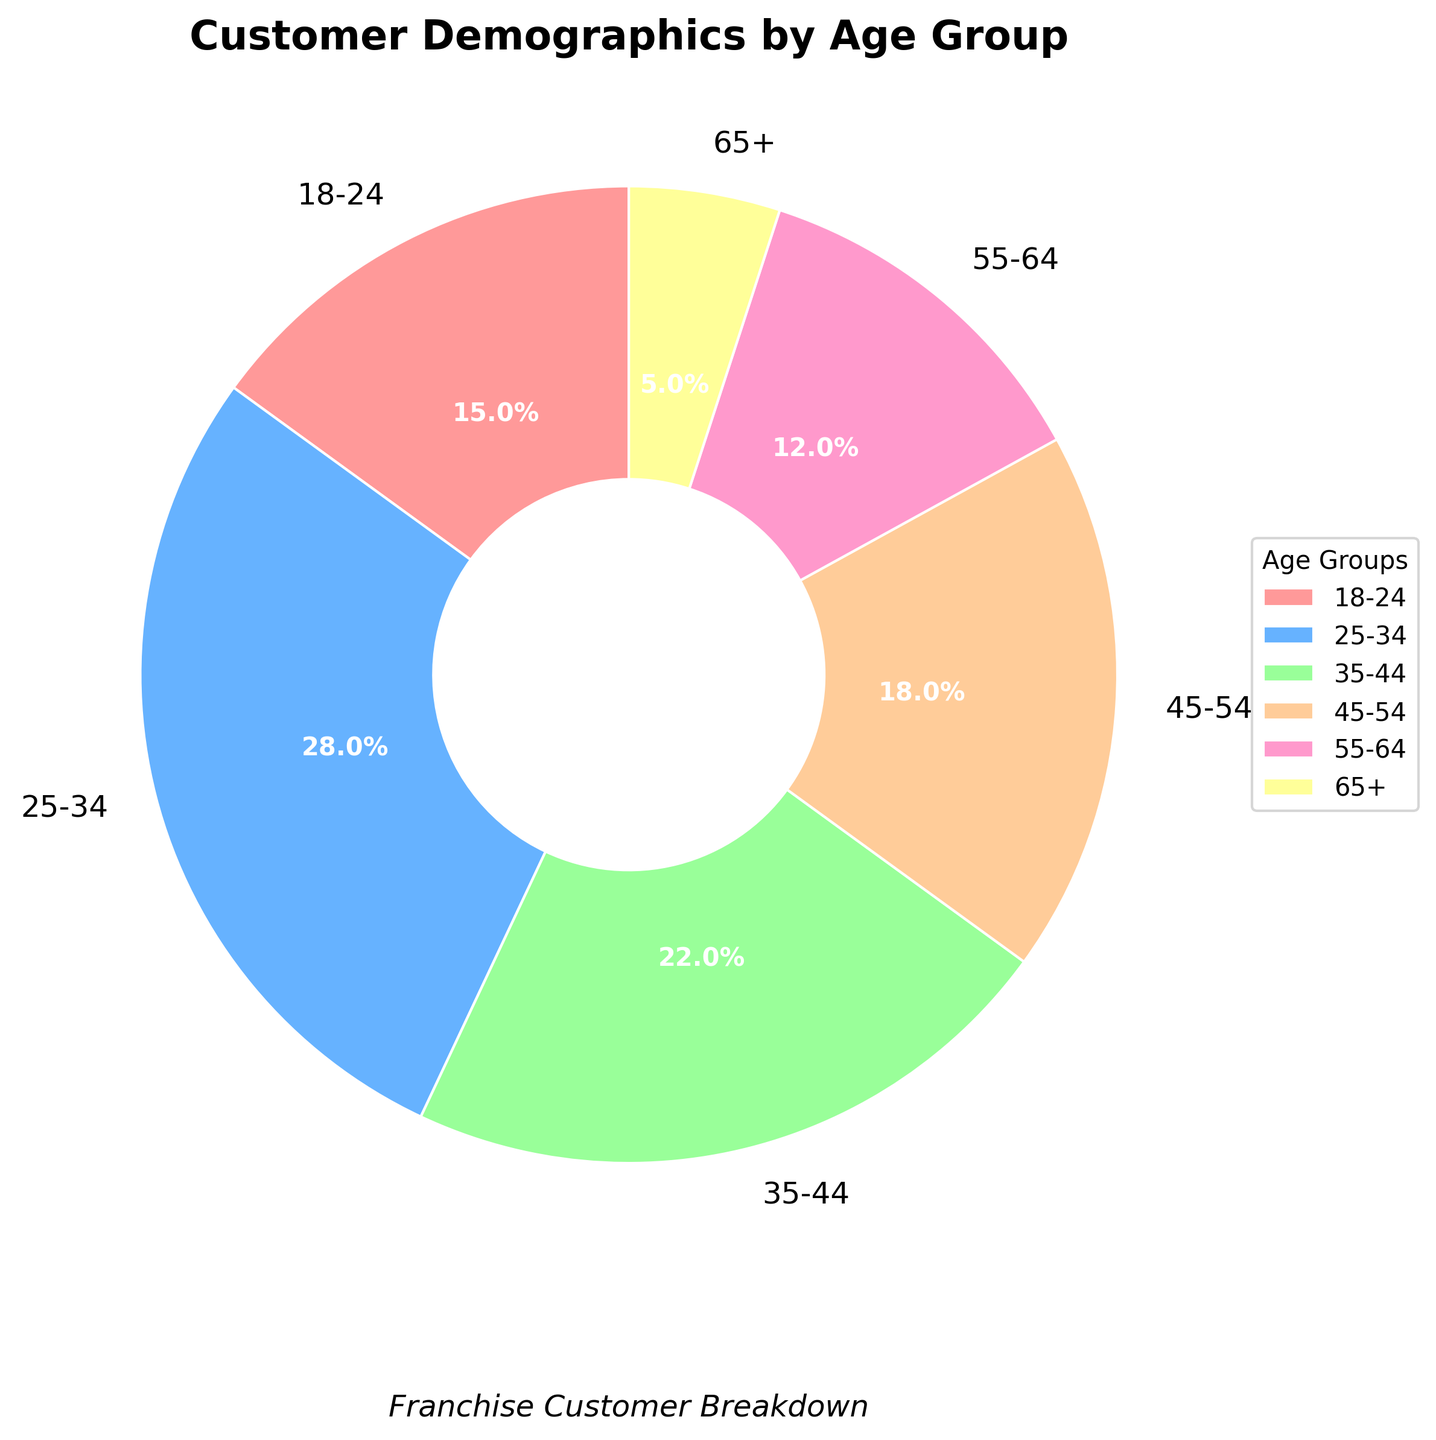Which age group has the highest percentage of customers? The pie chart shows the largest segment with a label indicating 28% for the 25-34 age group.
Answer: 25-34 What is the combined percentage of customers aged 45 and above? To find the combined percentage, add the percentages of age groups 45-54, 55-64, and 65+. These are 18%, 12%, and 5% respectively, so 18 + 12 + 5 = 35%.
Answer: 35% Which age group accounts for less than 10% of the customer base? The pie chart shows the smallest segment labeled 5% for the 65+ age group, which is less than 10%.
Answer: 65+ How much larger is the percentage of customers aged 25-34 compared to those aged 55-64? Subtract the percentage of customers aged 55-64 from those aged 25-34. So, 28% - 12% = 16%.
Answer: 16% Are there more customers aged 35-44 or 45-54? The pie chart shows 22% for the 35-44 age group and 18% for the 45-54 age group. 22% is greater than 18%.
Answer: 35-44 What percentage of customers is aged 18-24? The pie chart shows the percentage of the 18-24 age group as 15%.
Answer: 15% How many age groups have more than 20% of the customers? The pie chart indicates that only two age groups have more than 20%: 25-34 (28%) and 35-44 (22%).
Answer: 2 Which two age groups combined have nearly the same percentage as the 25-34 age group? Combining 18-24 and 55-64 age groups will give 15% + 12% = 27%, which is nearly 28%.
Answer: 18-24 and 55-64 What is the difference in percentage between the oldest and youngest age groups? Subtract the percentage of the 65+ group from the 18-24 group. So, 15% - 5% = 10%.
Answer: 10% Which age group is represented by the red segment in the pie chart? The pie chart colors are in the default order, where the first segment is red, which corresponds to the 18-24 age group.
Answer: 18-24 